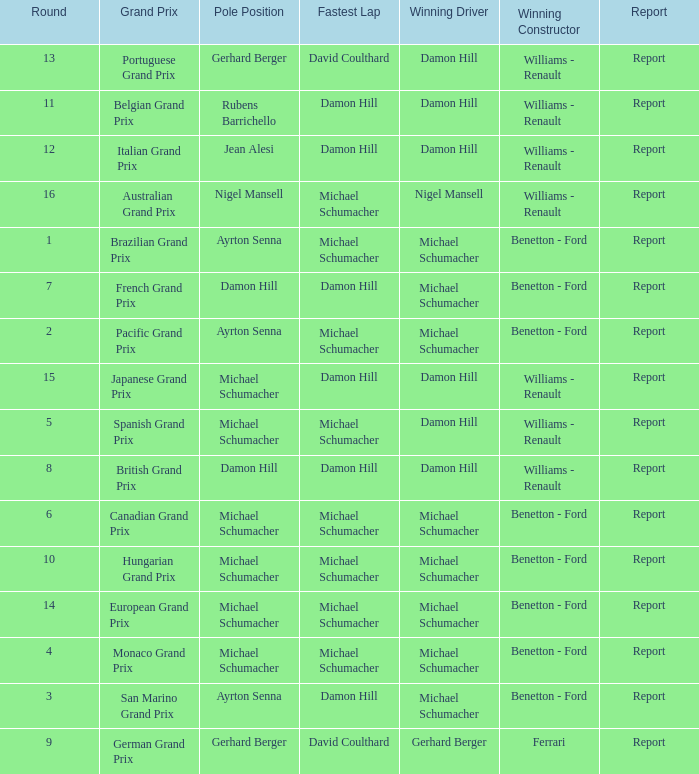Name the lowest round for when pole position and winning driver is michael schumacher 4.0. 